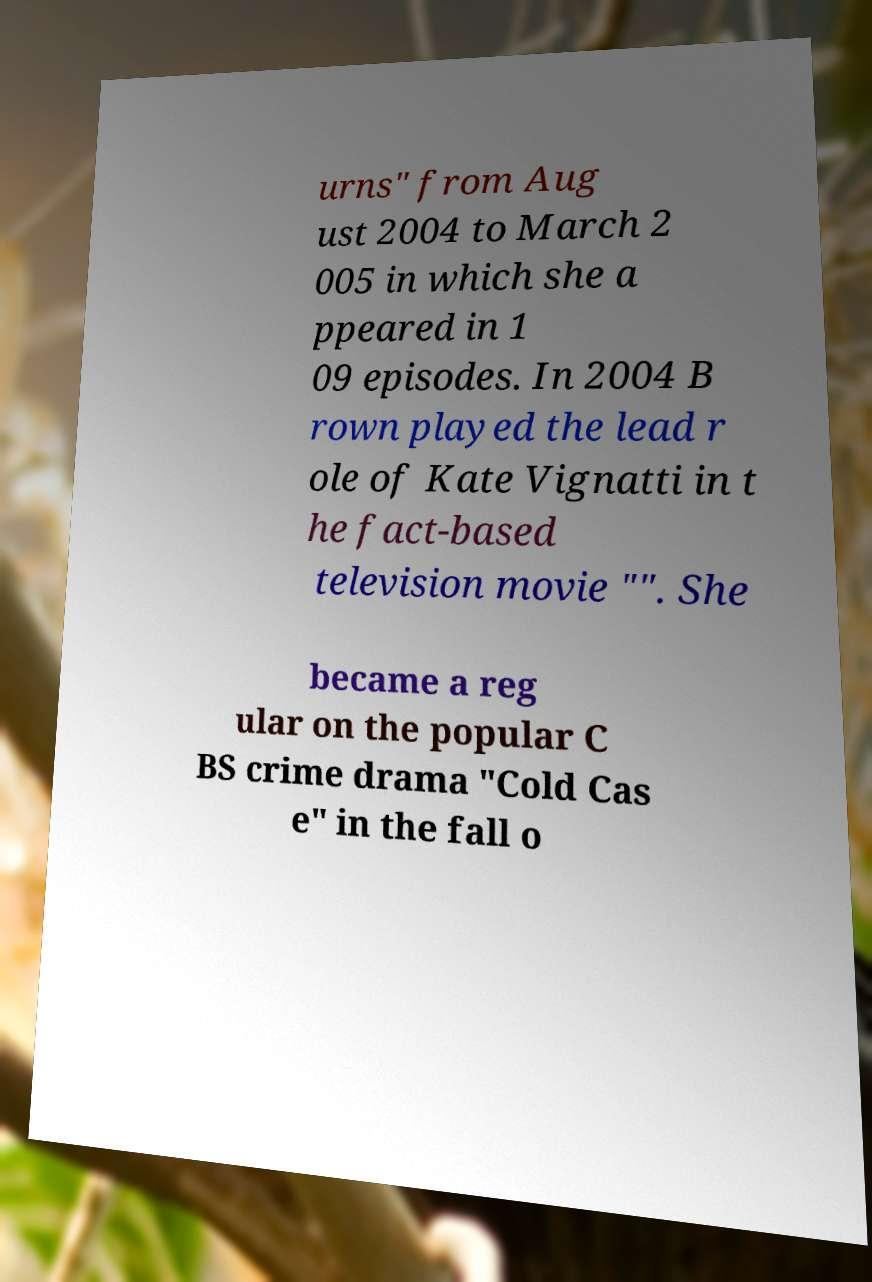For documentation purposes, I need the text within this image transcribed. Could you provide that? urns" from Aug ust 2004 to March 2 005 in which she a ppeared in 1 09 episodes. In 2004 B rown played the lead r ole of Kate Vignatti in t he fact-based television movie "". She became a reg ular on the popular C BS crime drama "Cold Cas e" in the fall o 